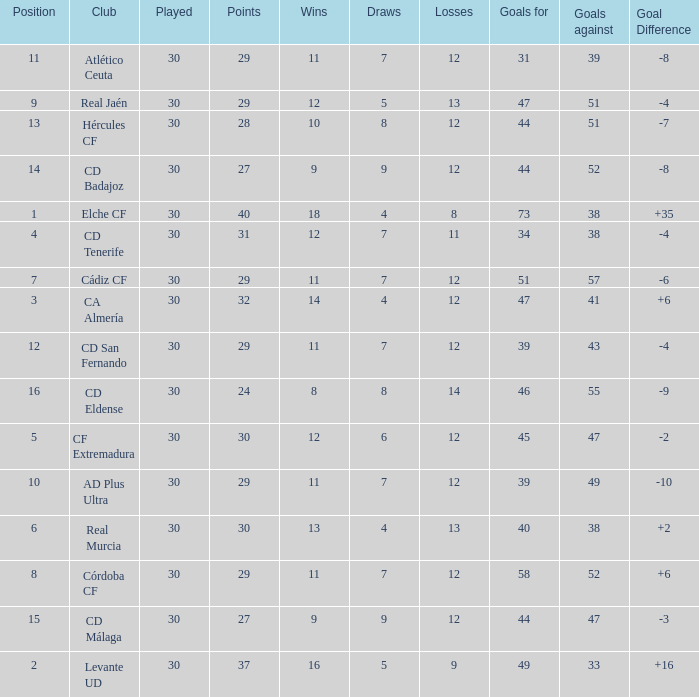What is the average number of goals against with more than 12 wins, 12 losses, and a position greater than 3? None. 